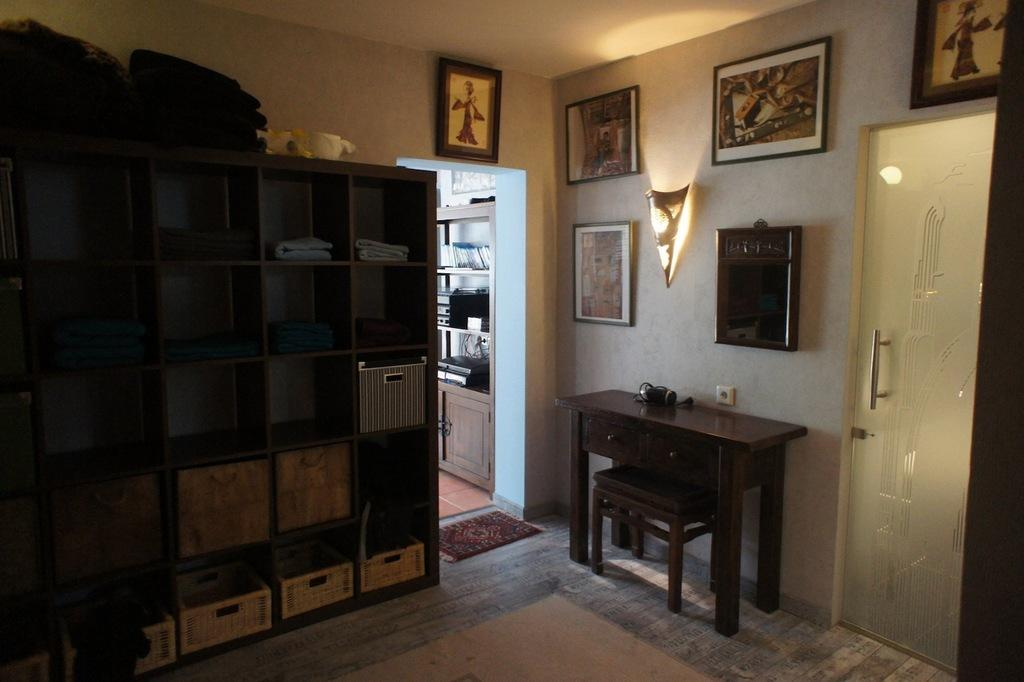What type of space is depicted in the image? There is a room in the image. What type of furniture can be seen in the room? There are cupboards and a table with items on it in the room. What type of decorations are present in the room? There are frames in the room. What type of lighting is available in the room? There is a lamp in the room. How can one enter or exit the room? There is a door in the room. What type of sticks can be seen in the image? There are no sticks present in the image. 